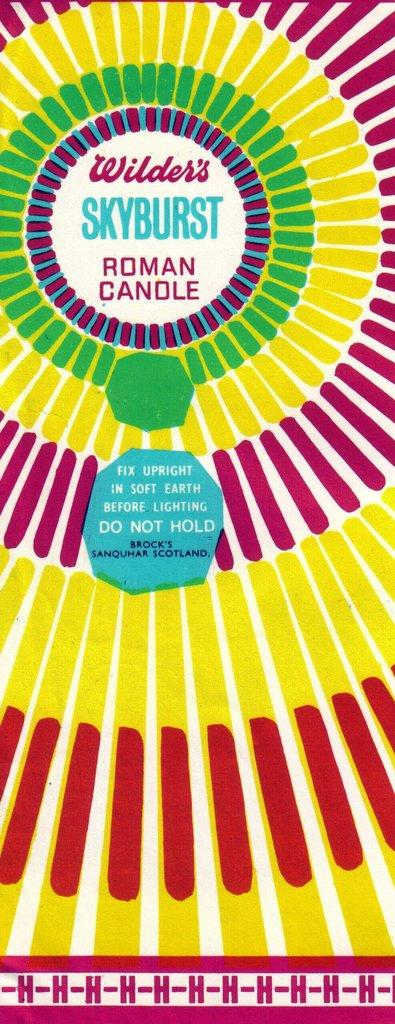<image>
Relay a brief, clear account of the picture shown. A label for Wilder's Skyburst Roman Candle has a spiral pattern. 